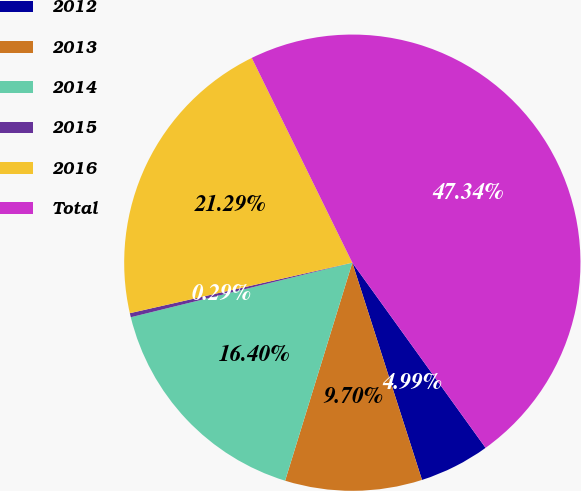<chart> <loc_0><loc_0><loc_500><loc_500><pie_chart><fcel>2012<fcel>2013<fcel>2014<fcel>2015<fcel>2016<fcel>Total<nl><fcel>4.99%<fcel>9.7%<fcel>16.4%<fcel>0.29%<fcel>21.29%<fcel>47.34%<nl></chart> 